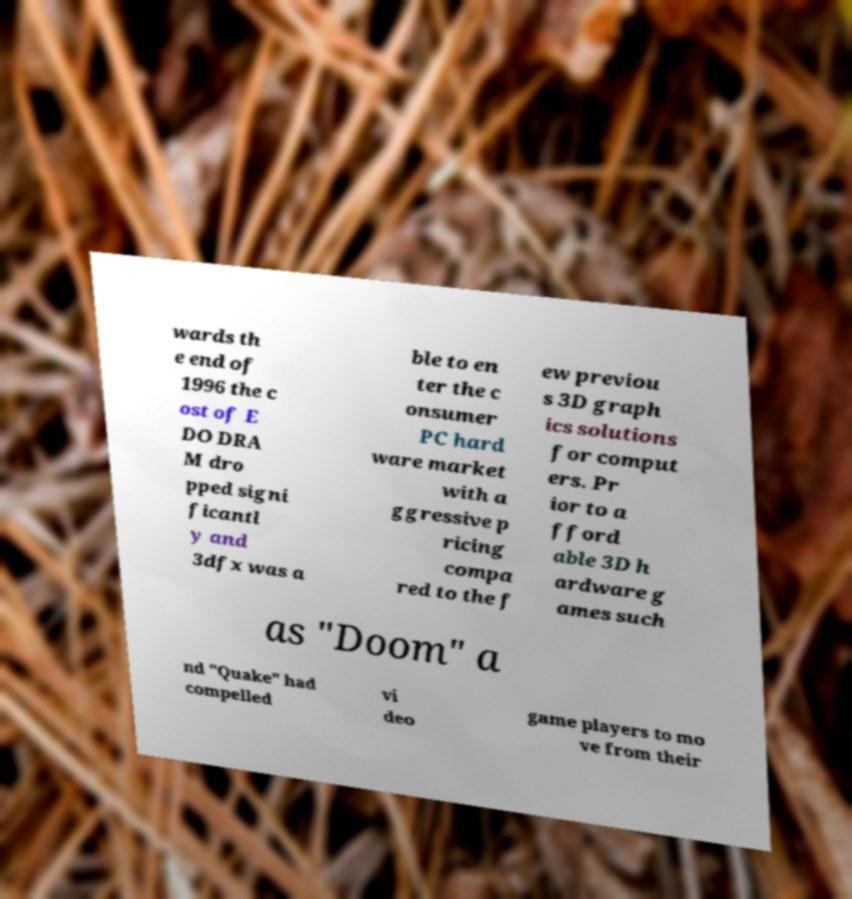Could you extract and type out the text from this image? wards th e end of 1996 the c ost of E DO DRA M dro pped signi ficantl y and 3dfx was a ble to en ter the c onsumer PC hard ware market with a ggressive p ricing compa red to the f ew previou s 3D graph ics solutions for comput ers. Pr ior to a fford able 3D h ardware g ames such as "Doom" a nd "Quake" had compelled vi deo game players to mo ve from their 